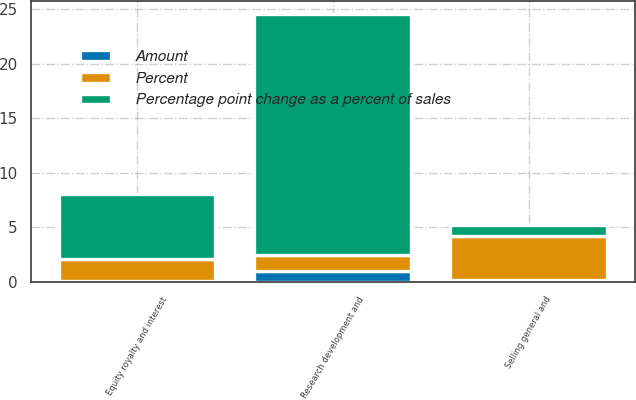<chart> <loc_0><loc_0><loc_500><loc_500><stacked_bar_chart><ecel><fcel>Selling general and<fcel>Research development and<fcel>Equity royalty and interest<nl><fcel>Percent<fcel>4<fcel>1.5<fcel>2<nl><fcel>Percentage point change as a percent of sales<fcel>1<fcel>22<fcel>6<nl><fcel>Amount<fcel>0.2<fcel>1<fcel>0.1<nl></chart> 